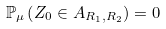<formula> <loc_0><loc_0><loc_500><loc_500>\mathbb { P } _ { \mu } \left ( Z _ { 0 } \in A _ { R _ { 1 } , R _ { 2 } } \right ) = 0</formula> 